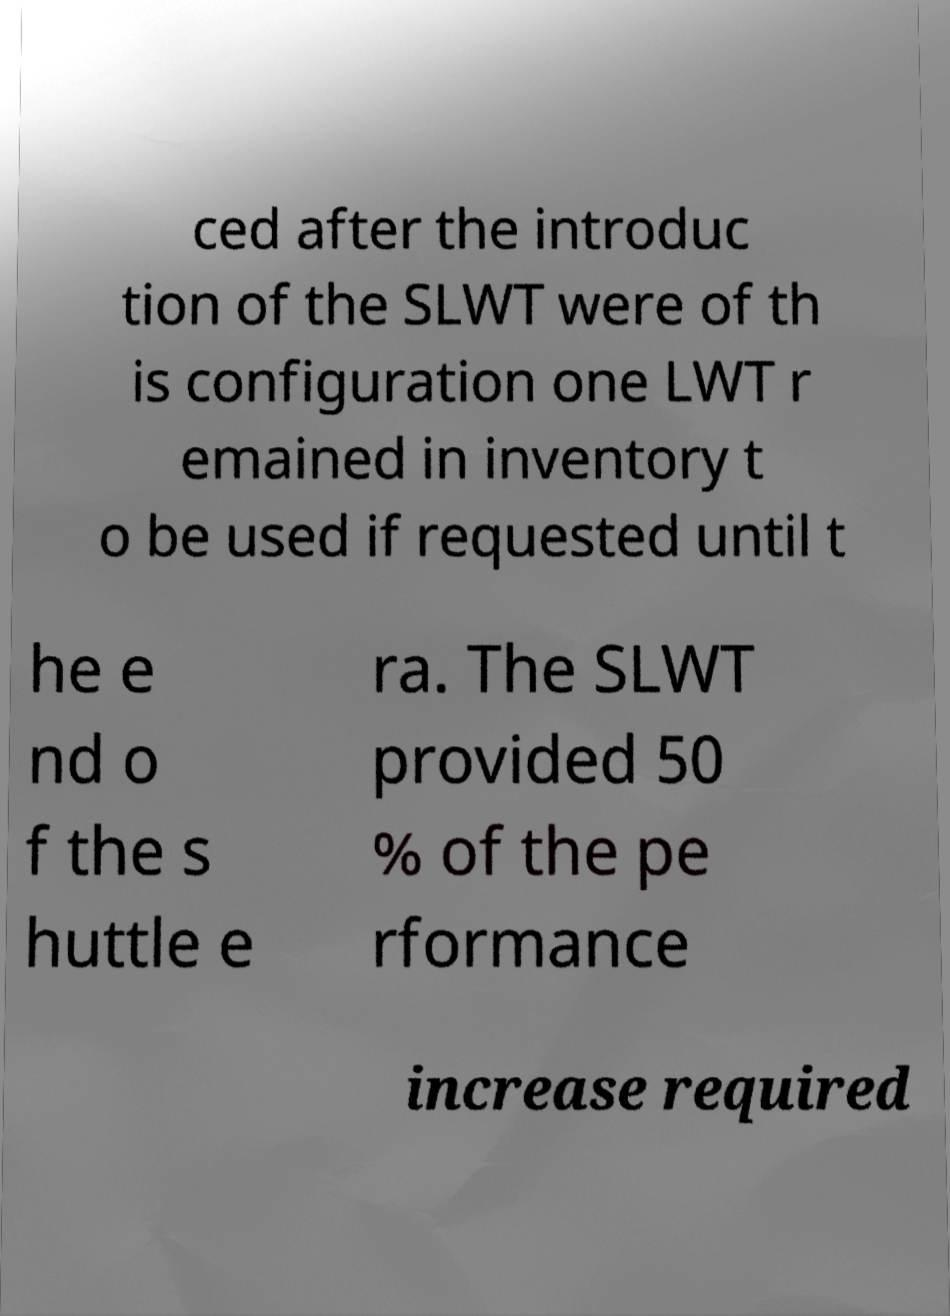There's text embedded in this image that I need extracted. Can you transcribe it verbatim? ced after the introduc tion of the SLWT were of th is configuration one LWT r emained in inventory t o be used if requested until t he e nd o f the s huttle e ra. The SLWT provided 50 % of the pe rformance increase required 